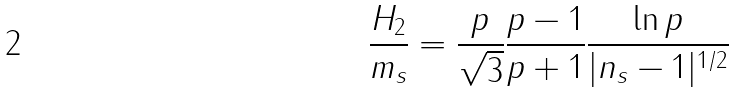<formula> <loc_0><loc_0><loc_500><loc_500>\frac { H _ { 2 } } { m _ { s } } = \frac { p } { \sqrt { 3 } } \frac { p - 1 } { p + 1 } \frac { \ln p } { | n _ { s } - 1 | ^ { 1 / 2 } }</formula> 